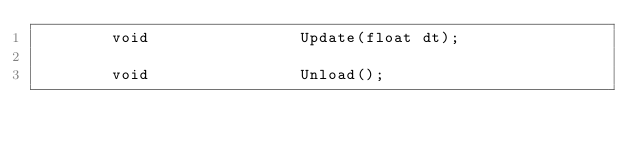<code> <loc_0><loc_0><loc_500><loc_500><_C_>        void                Update(float dt);

        void                Unload();
</code> 